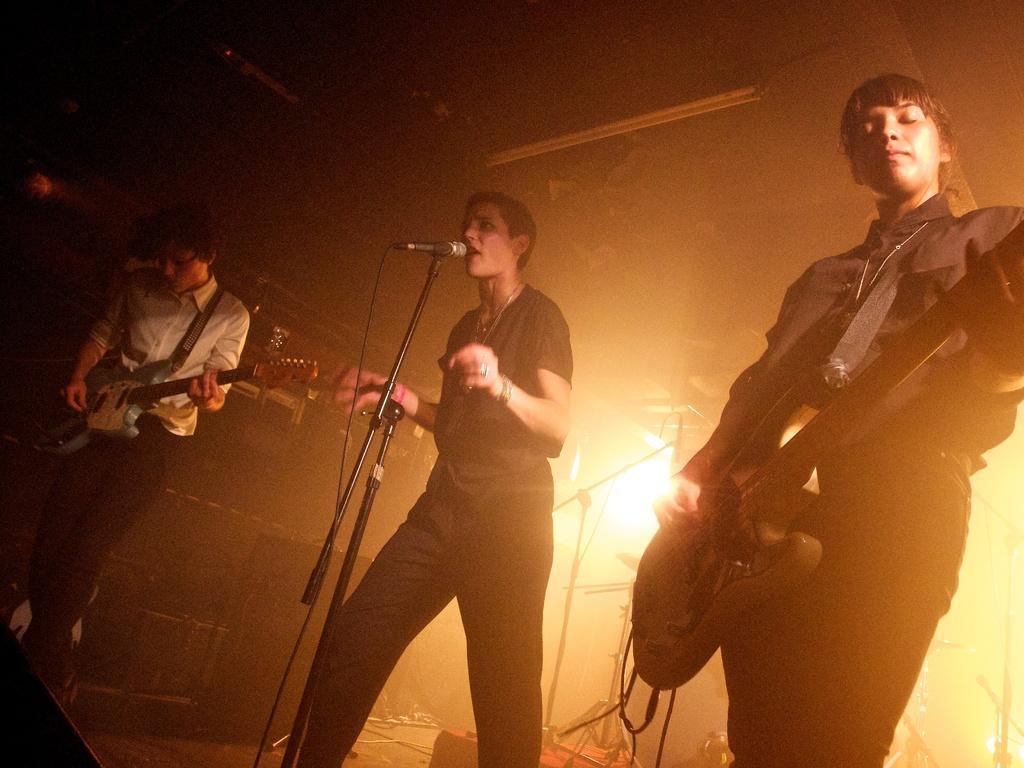In one or two sentences, can you explain what this image depicts? In the image, it is a concert, there are three people standing and playing the music the middle person is singing a song, in the background there is a lot of sunlight focusing into the room. 